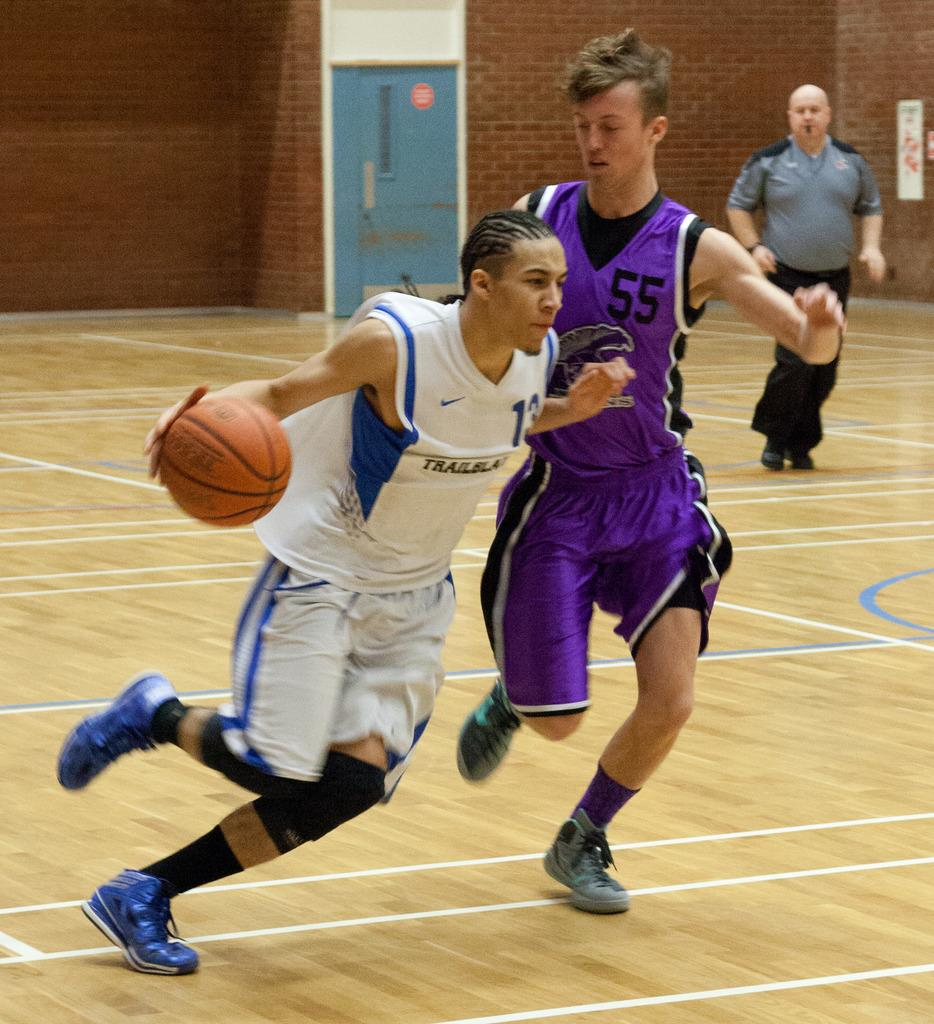What are the boys in the foreground of the image doing? The boys are playing in the foreground of the image. What can be seen in the background of the image? There is a door, a person, and a poster in the background of the image. How many shoes are on the ground in the image? There is no mention of shoes in the image, so it is impossible to determine how many there are. 